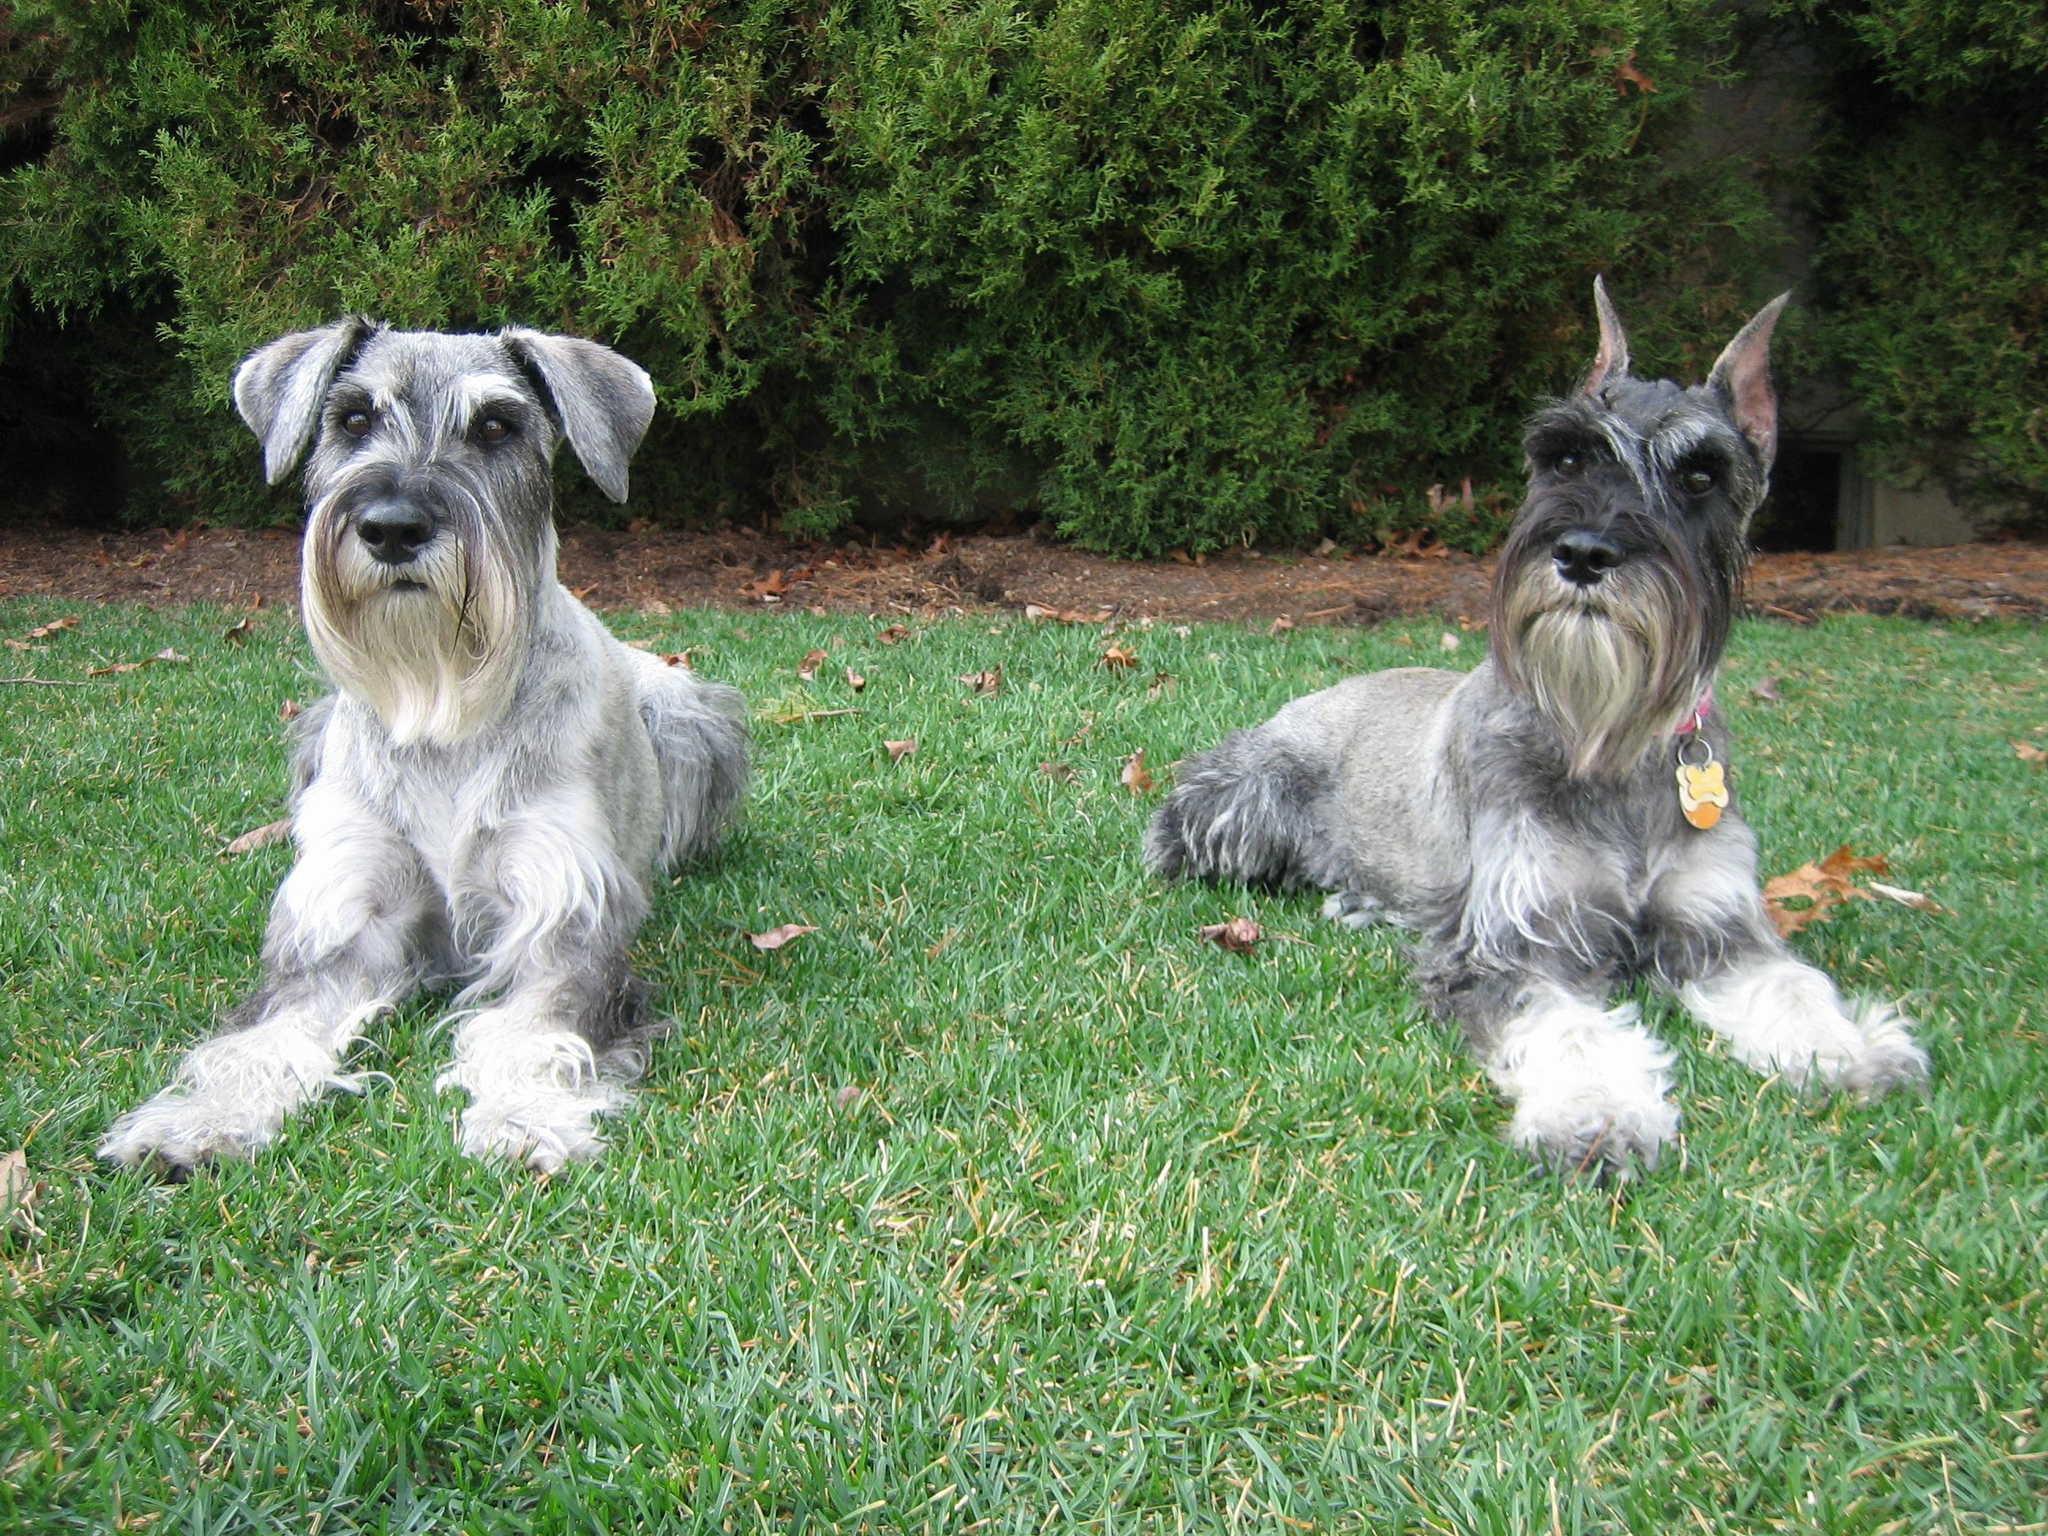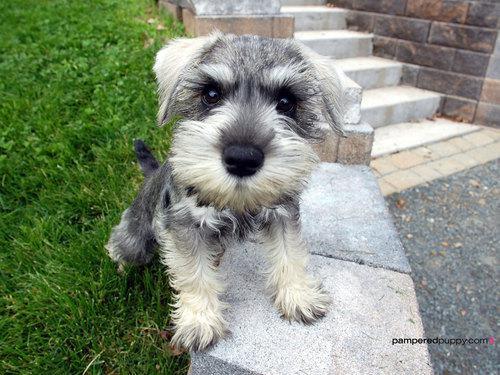The first image is the image on the left, the second image is the image on the right. Examine the images to the left and right. Is the description "There are three dogs" accurate? Answer yes or no. Yes. The first image is the image on the left, the second image is the image on the right. Evaluate the accuracy of this statement regarding the images: "In one image there is a dog sitting in grass.". Is it true? Answer yes or no. No. The first image is the image on the left, the second image is the image on the right. For the images displayed, is the sentence "Two schnauzers pose in the grass in one image." factually correct? Answer yes or no. Yes. The first image is the image on the left, the second image is the image on the right. Evaluate the accuracy of this statement regarding the images: "The right image has a dog with it's from feet propped on stone while looking at the camera". Is it true? Answer yes or no. Yes. 